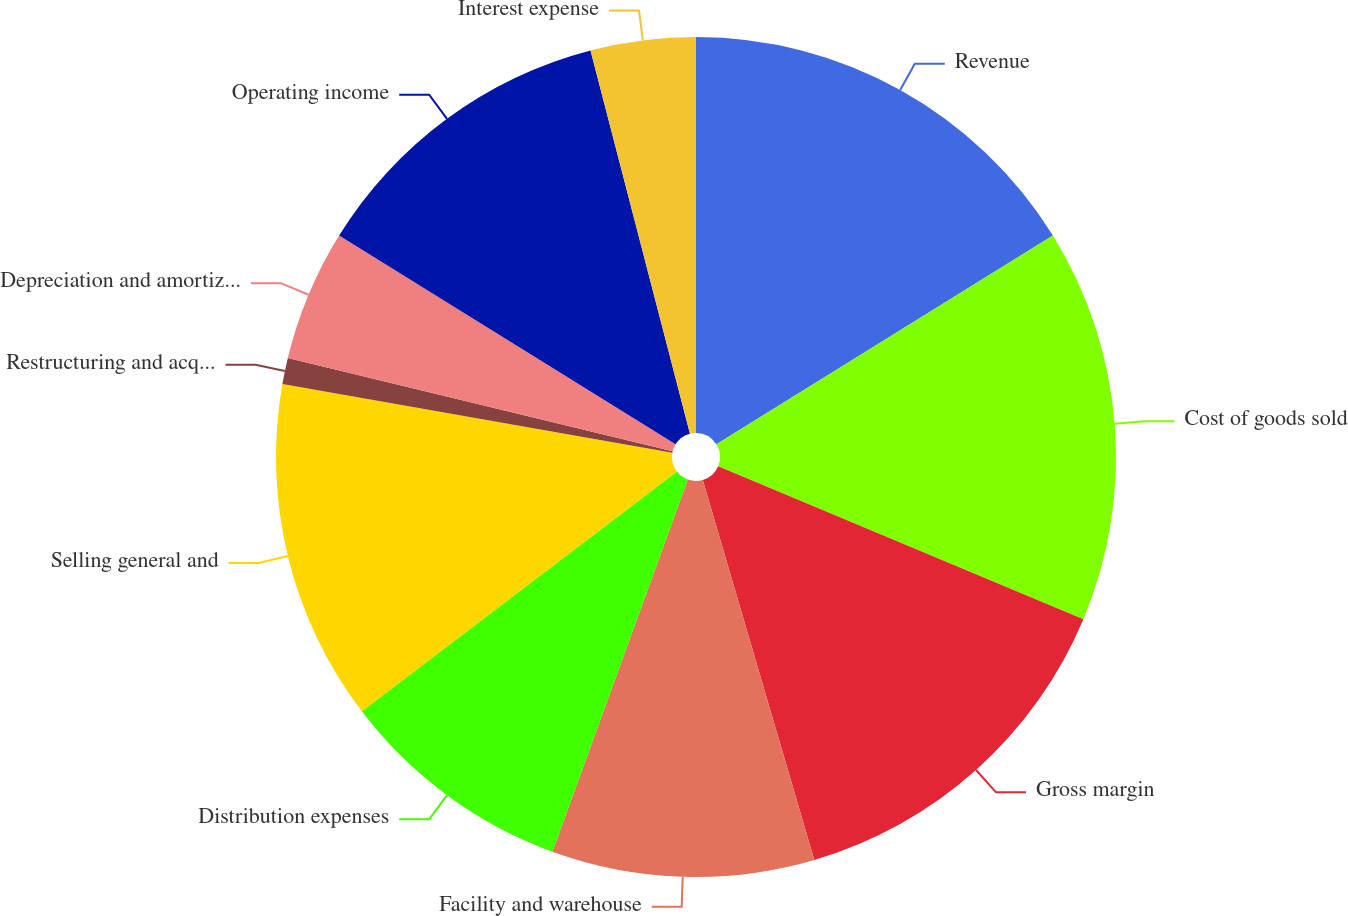<chart> <loc_0><loc_0><loc_500><loc_500><pie_chart><fcel>Revenue<fcel>Cost of goods sold<fcel>Gross margin<fcel>Facility and warehouse<fcel>Distribution expenses<fcel>Selling general and<fcel>Restructuring and acquisition<fcel>Depreciation and amortization<fcel>Operating income<fcel>Interest expense<nl><fcel>16.16%<fcel>15.15%<fcel>14.14%<fcel>10.1%<fcel>9.09%<fcel>13.13%<fcel>1.01%<fcel>5.05%<fcel>12.12%<fcel>4.04%<nl></chart> 